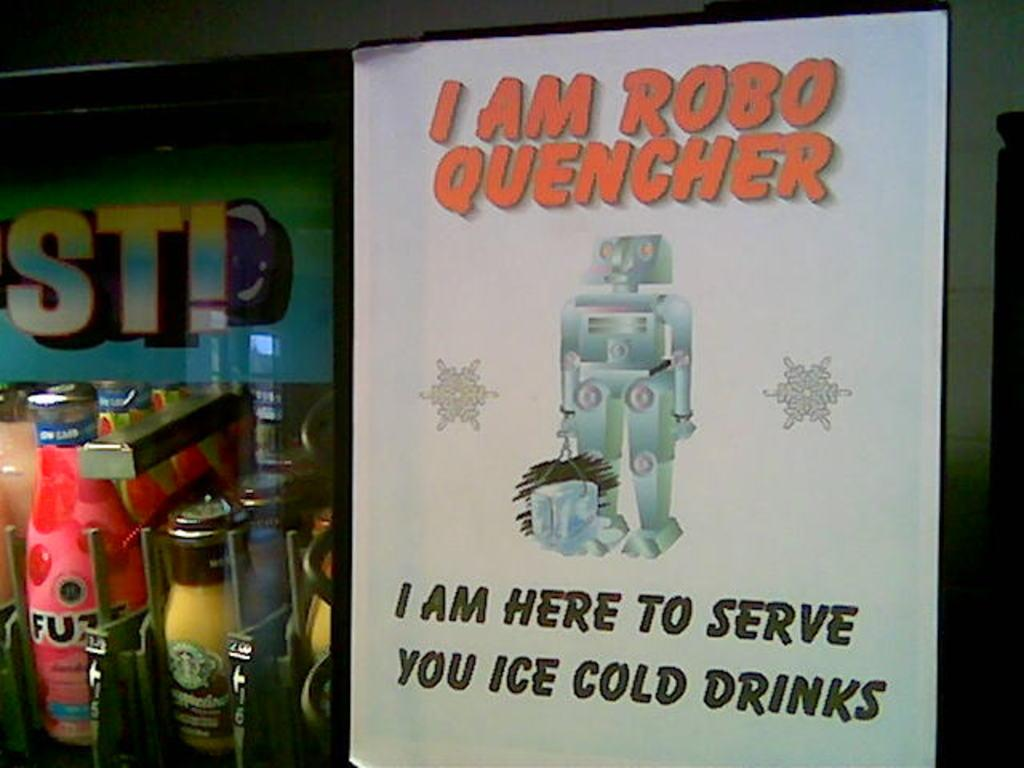Provide a one-sentence caption for the provided image. A cold drink robot server called, ROBO QUENCHER. 